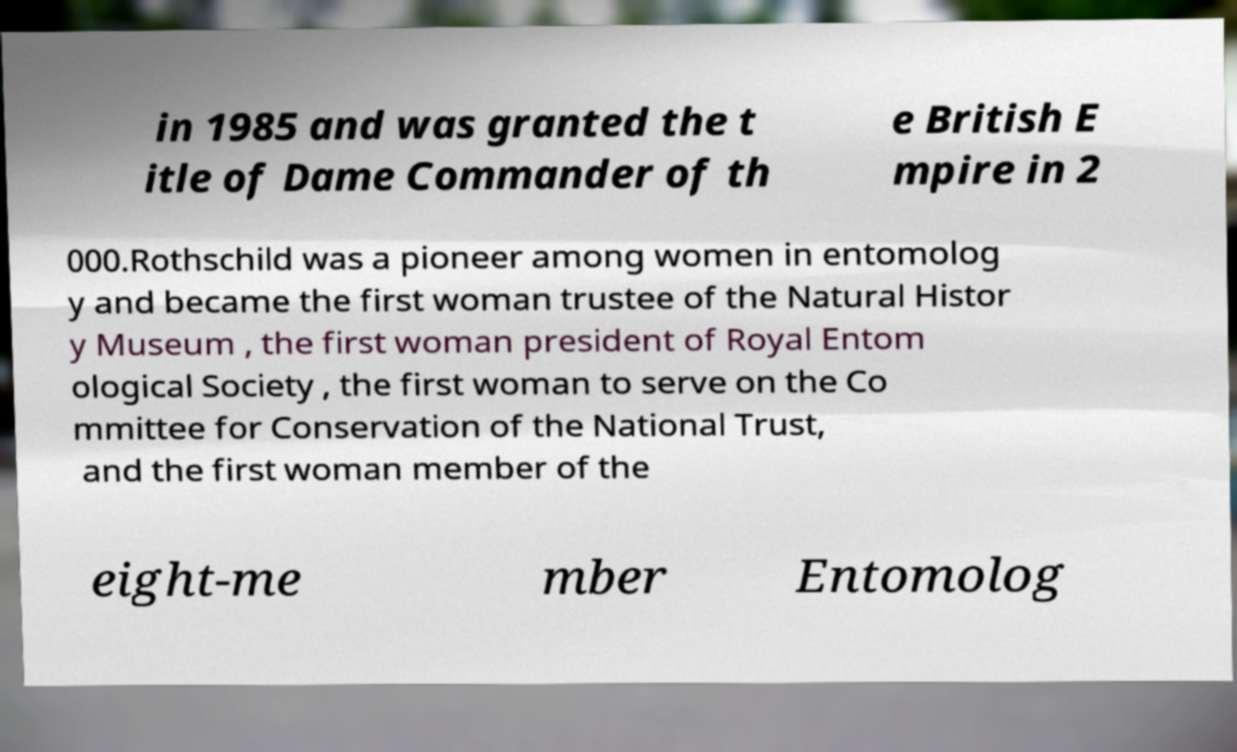Could you extract and type out the text from this image? in 1985 and was granted the t itle of Dame Commander of th e British E mpire in 2 000.Rothschild was a pioneer among women in entomolog y and became the first woman trustee of the Natural Histor y Museum , the first woman president of Royal Entom ological Society , the first woman to serve on the Co mmittee for Conservation of the National Trust, and the first woman member of the eight-me mber Entomolog 